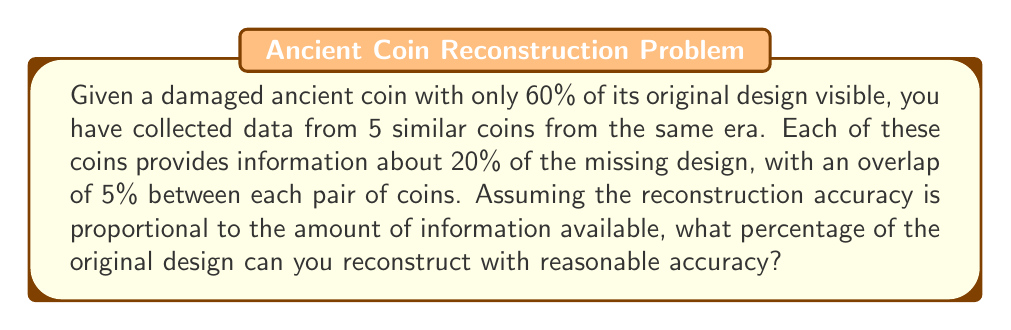Provide a solution to this math problem. Let's approach this step-by-step:

1) First, we know that 60% of the original design is visible on the damaged coin. Let's call this $A$.

   $A = 60\%$

2) We have 5 similar coins, each providing 20% of the missing design. However, there's an overlap of 5% between each pair of coins. Let's calculate the unique information provided by each coin:

   First coin: 20%
   Second coin: 20% - 5% (overlap) = 15%
   Third coin: 20% - 5% - 5% = 10%
   Fourth coin: 20% - 5% - 5% - 5% = 5%
   Fifth coin: 20% - 5% - 5% - 5% - 5% = 0%

3) Let's sum up the unique information from these coins. Call this $B$.

   $B = 20\% + 15\% + 10\% + 5\% + 0\% = 50\%$

4) However, this 50% is of the missing 40% of the design. To get the actual percentage of the total design, we need to calculate:

   $C = 40\% \times 50\% = 20\%$

5) Now, we can add this to the original visible design:

   $Total = A + C = 60\% + 20\% = 80\%$

Therefore, you can reconstruct 80% of the original design with reasonable accuracy.
Answer: 80% 